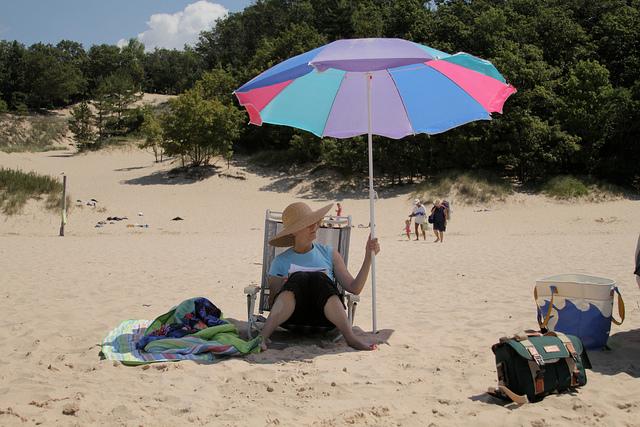Is it raining?
Answer briefly. No. Is the woman wearing a hat?
Answer briefly. Yes. What color is the right top umbrella?
Short answer required. Pink. Are any chairs empty?
Write a very short answer. No. Is the umbrella open?
Write a very short answer. Yes. 